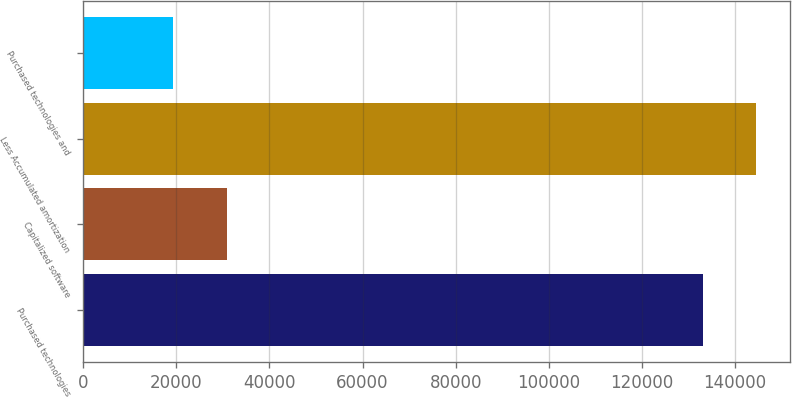Convert chart to OTSL. <chart><loc_0><loc_0><loc_500><loc_500><bar_chart><fcel>Purchased technologies<fcel>Capitalized software<fcel>Less Accumulated amortization<fcel>Purchased technologies and<nl><fcel>133041<fcel>30894<fcel>144557<fcel>19378<nl></chart> 